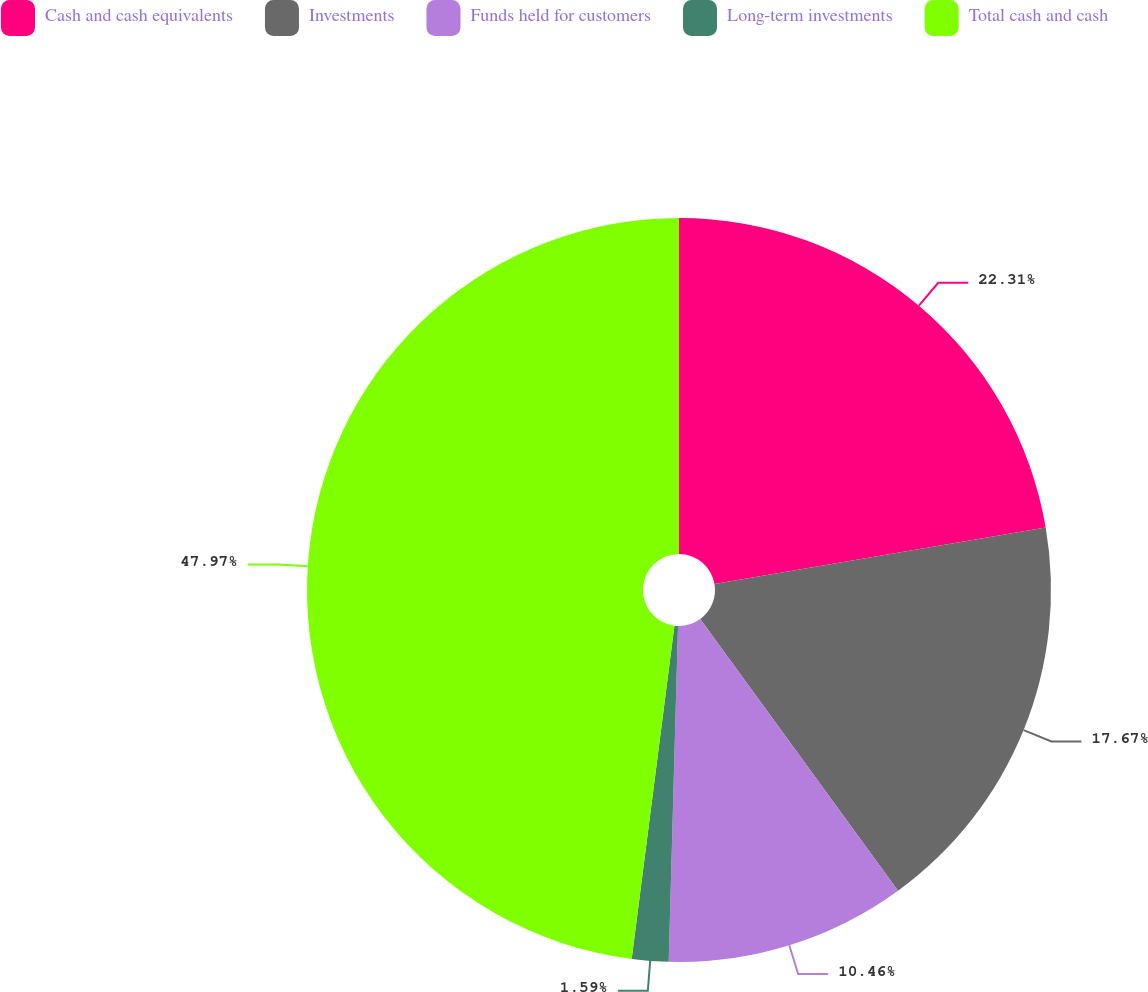Convert chart to OTSL. <chart><loc_0><loc_0><loc_500><loc_500><pie_chart><fcel>Cash and cash equivalents<fcel>Investments<fcel>Funds held for customers<fcel>Long-term investments<fcel>Total cash and cash<nl><fcel>22.31%<fcel>17.67%<fcel>10.46%<fcel>1.59%<fcel>47.97%<nl></chart> 